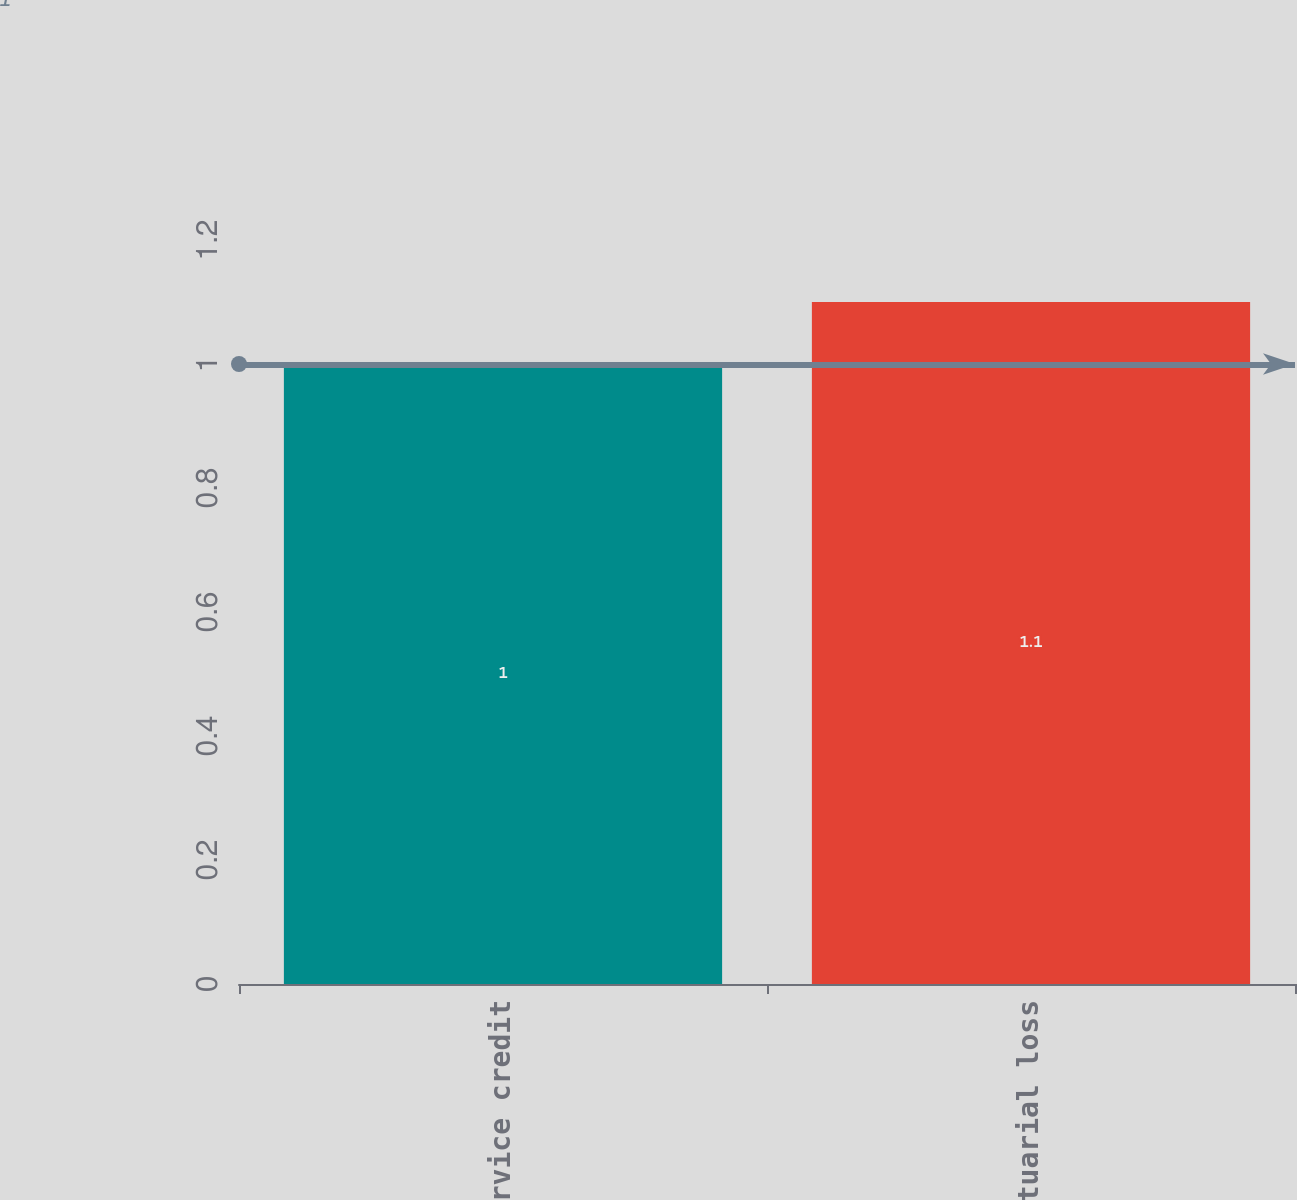Convert chart to OTSL. <chart><loc_0><loc_0><loc_500><loc_500><bar_chart><fcel>Prior service credit<fcel>Net actuarial loss<nl><fcel>1<fcel>1.1<nl></chart> 